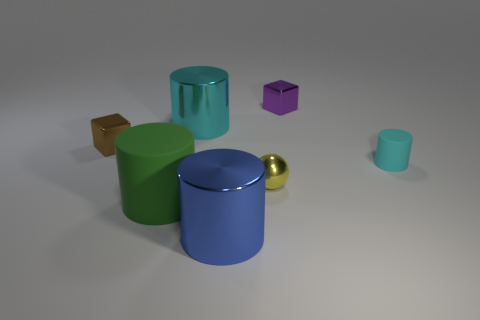There is a big metal object that is the same color as the small rubber cylinder; what shape is it?
Give a very brief answer. Cylinder. How many small things are yellow things or brown objects?
Your answer should be very brief. 2. Is the number of small gray metallic cylinders greater than the number of big matte cylinders?
Provide a short and direct response. No. There is a matte cylinder in front of the cyan cylinder that is to the right of the purple cube; how many large shiny cylinders are to the right of it?
Your answer should be compact. 2. What shape is the blue object?
Keep it short and to the point. Cylinder. How many other objects are the same material as the small cylinder?
Offer a very short reply. 1. Is the size of the brown metal object the same as the green object?
Offer a very short reply. No. What is the shape of the large metal thing that is behind the big matte thing?
Ensure brevity in your answer.  Cylinder. What is the color of the big cylinder behind the cyan cylinder right of the blue cylinder?
Your answer should be compact. Cyan. Is the shape of the large thing that is behind the green matte object the same as the metal thing that is behind the cyan metallic thing?
Provide a succinct answer. No. 